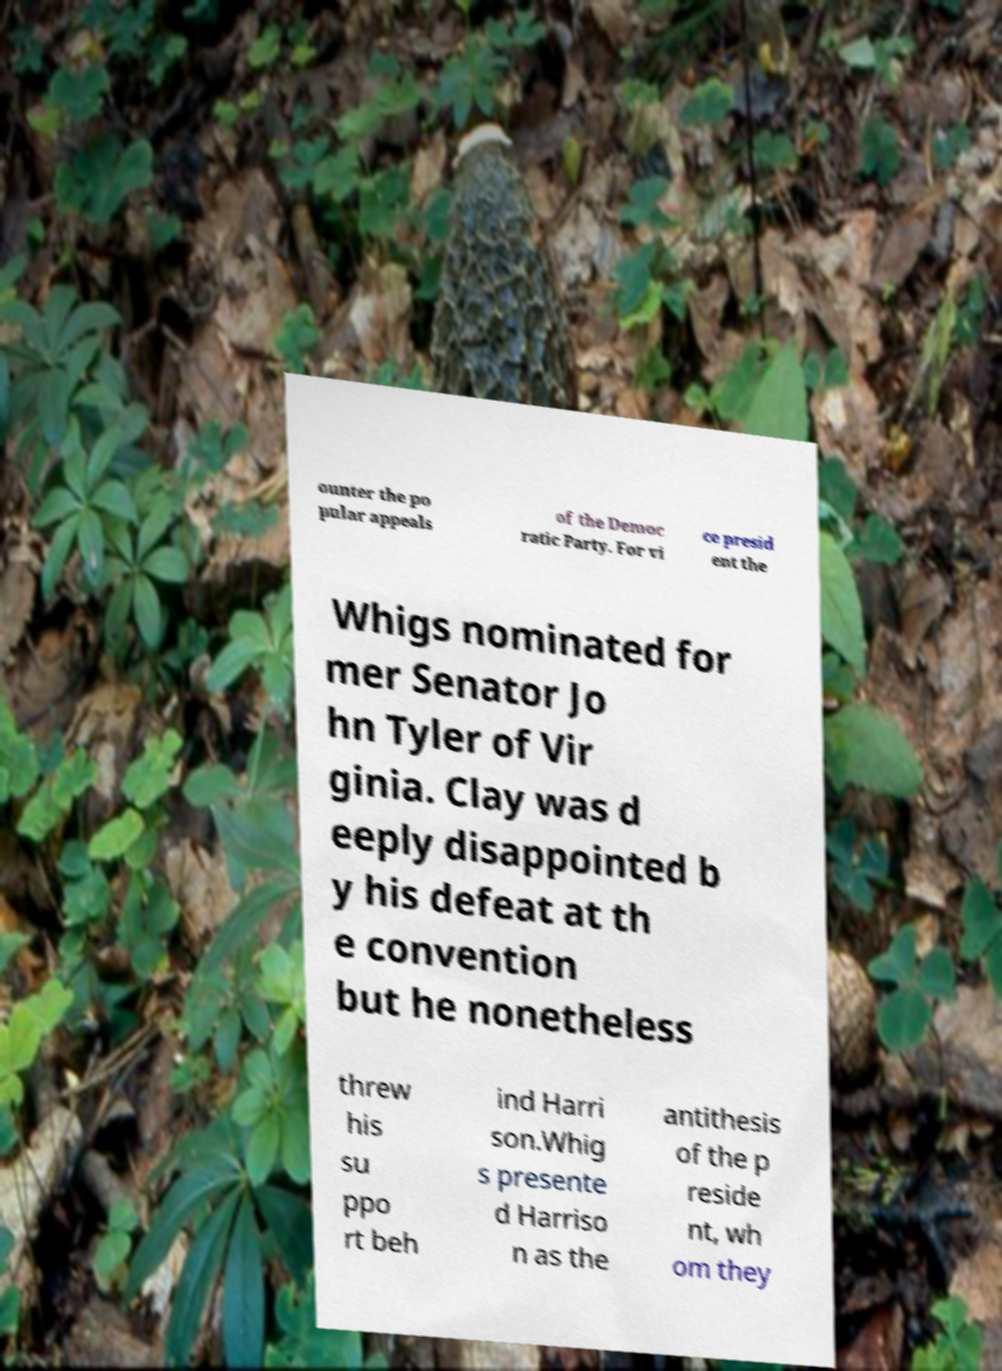What messages or text are displayed in this image? I need them in a readable, typed format. ounter the po pular appeals of the Democ ratic Party. For vi ce presid ent the Whigs nominated for mer Senator Jo hn Tyler of Vir ginia. Clay was d eeply disappointed b y his defeat at th e convention but he nonetheless threw his su ppo rt beh ind Harri son.Whig s presente d Harriso n as the antithesis of the p reside nt, wh om they 